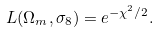<formula> <loc_0><loc_0><loc_500><loc_500>L ( \Omega _ { m } , \sigma _ { 8 } ) = e ^ { - \chi ^ { 2 } / 2 } .</formula> 